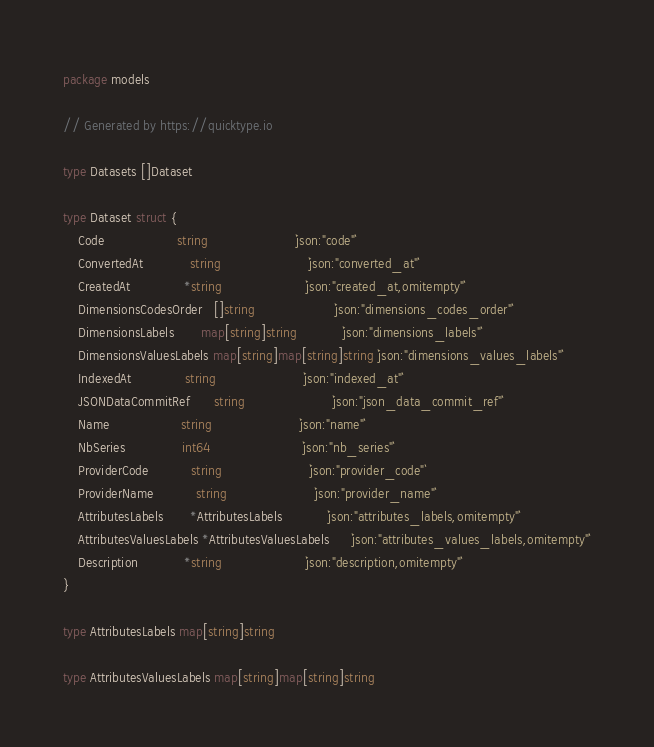Convert code to text. <code><loc_0><loc_0><loc_500><loc_500><_Go_>package models

// Generated by https://quicktype.io

type Datasets []Dataset

type Dataset struct {
	Code                   string                       `json:"code"`
	ConvertedAt            string                       `json:"converted_at"`
	CreatedAt              *string                      `json:"created_at,omitempty"`
	DimensionsCodesOrder   []string                     `json:"dimensions_codes_order"`
	DimensionsLabels       map[string]string            `json:"dimensions_labels"`
	DimensionsValuesLabels map[string]map[string]string `json:"dimensions_values_labels"`
	IndexedAt              string                       `json:"indexed_at"`
	JSONDataCommitRef      string                       `json:"json_data_commit_ref"`
	Name                   string                       `json:"name"`
	NbSeries               int64                        `json:"nb_series"`
	ProviderCode           string                       `json:"provider_code"`
	ProviderName           string                       `json:"provider_name"`
	AttributesLabels       *AttributesLabels            `json:"attributes_labels,omitempty"`
	AttributesValuesLabels *AttributesValuesLabels      `json:"attributes_values_labels,omitempty"`
	Description            *string                      `json:"description,omitempty"`
}

type AttributesLabels map[string]string

type AttributesValuesLabels map[string]map[string]string
</code> 